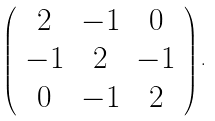<formula> <loc_0><loc_0><loc_500><loc_500>\left ( \begin{array} { c c c } 2 & - 1 & 0 \\ - 1 & 2 & - 1 \\ 0 & - 1 & 2 \end{array} \right ) .</formula> 